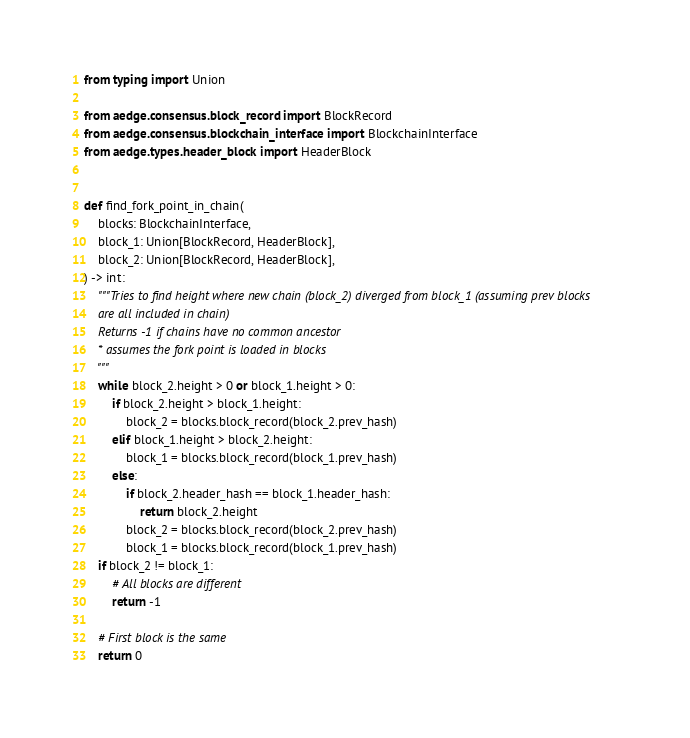<code> <loc_0><loc_0><loc_500><loc_500><_Python_>from typing import Union

from aedge.consensus.block_record import BlockRecord
from aedge.consensus.blockchain_interface import BlockchainInterface
from aedge.types.header_block import HeaderBlock


def find_fork_point_in_chain(
    blocks: BlockchainInterface,
    block_1: Union[BlockRecord, HeaderBlock],
    block_2: Union[BlockRecord, HeaderBlock],
) -> int:
    """Tries to find height where new chain (block_2) diverged from block_1 (assuming prev blocks
    are all included in chain)
    Returns -1 if chains have no common ancestor
    * assumes the fork point is loaded in blocks
    """
    while block_2.height > 0 or block_1.height > 0:
        if block_2.height > block_1.height:
            block_2 = blocks.block_record(block_2.prev_hash)
        elif block_1.height > block_2.height:
            block_1 = blocks.block_record(block_1.prev_hash)
        else:
            if block_2.header_hash == block_1.header_hash:
                return block_2.height
            block_2 = blocks.block_record(block_2.prev_hash)
            block_1 = blocks.block_record(block_1.prev_hash)
    if block_2 != block_1:
        # All blocks are different
        return -1

    # First block is the same
    return 0
</code> 